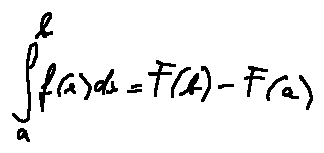Convert formula to latex. <formula><loc_0><loc_0><loc_500><loc_500>\int \lim i t s _ { a } ^ { b } f ( x ) d x = F ( b ) - F ( a )</formula> 